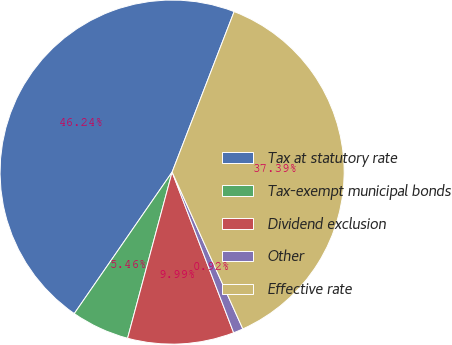Convert chart. <chart><loc_0><loc_0><loc_500><loc_500><pie_chart><fcel>Tax at statutory rate<fcel>Tax-exempt municipal bonds<fcel>Dividend exclusion<fcel>Other<fcel>Effective rate<nl><fcel>46.24%<fcel>5.46%<fcel>9.99%<fcel>0.92%<fcel>37.39%<nl></chart> 